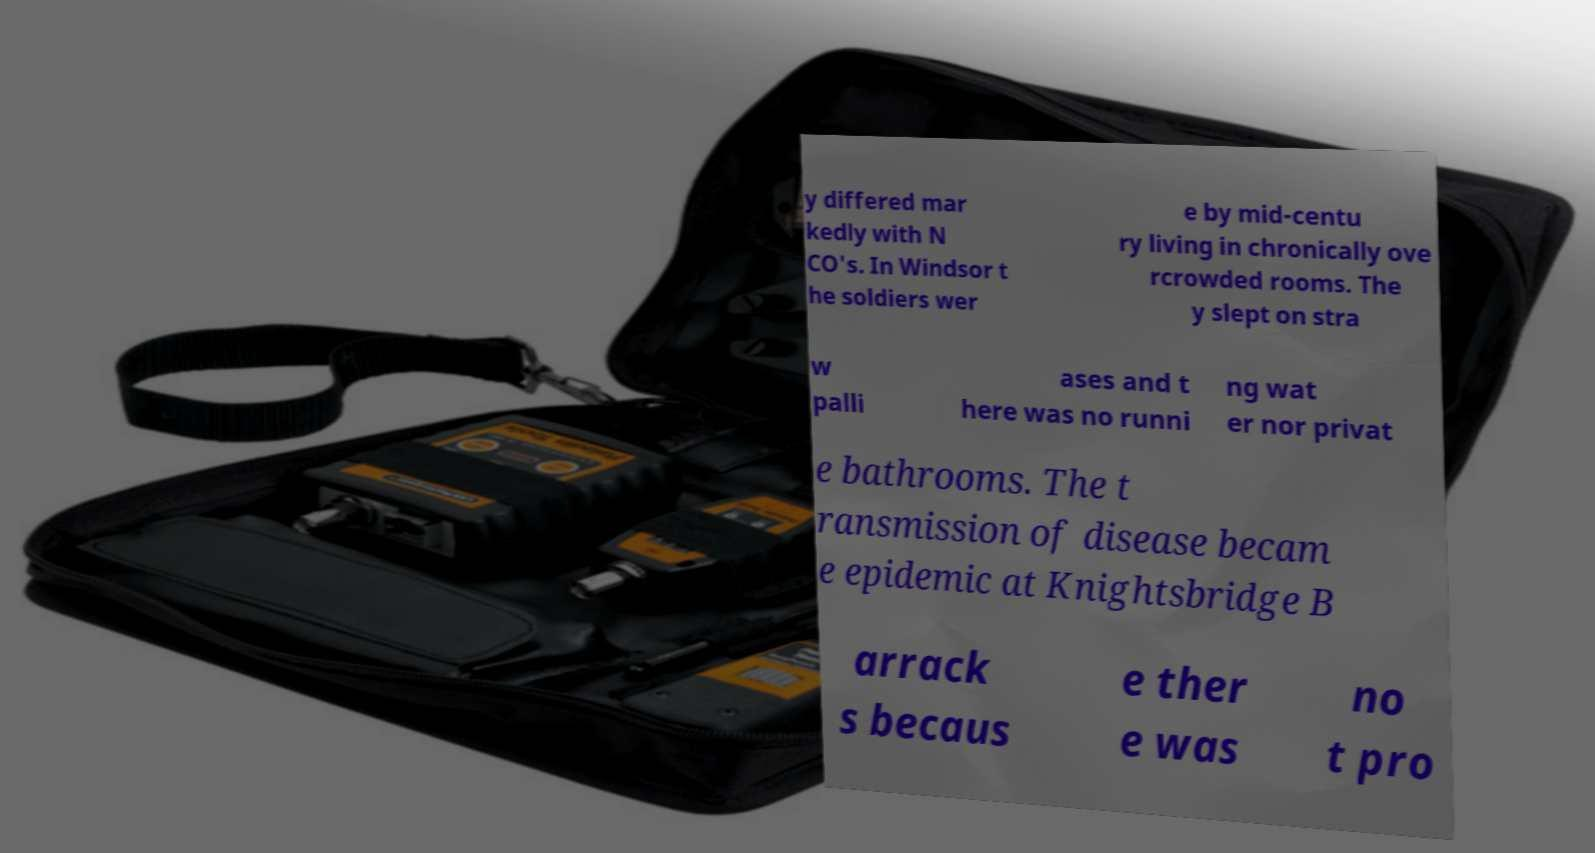What messages or text are displayed in this image? I need them in a readable, typed format. y differed mar kedly with N CO's. In Windsor t he soldiers wer e by mid-centu ry living in chronically ove rcrowded rooms. The y slept on stra w palli ases and t here was no runni ng wat er nor privat e bathrooms. The t ransmission of disease becam e epidemic at Knightsbridge B arrack s becaus e ther e was no t pro 